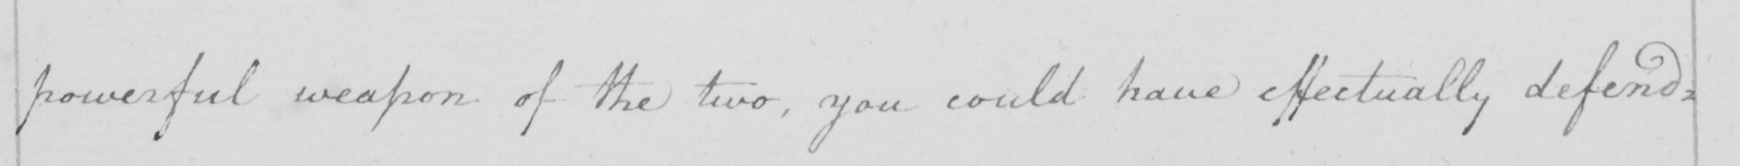Transcribe the text shown in this historical manuscript line. powerful weapon of the two, you could have effectually defend= 